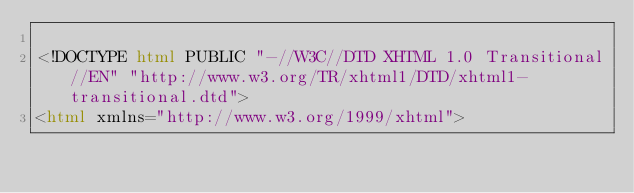Convert code to text. <code><loc_0><loc_0><loc_500><loc_500><_HTML_>
<!DOCTYPE html PUBLIC "-//W3C//DTD XHTML 1.0 Transitional//EN" "http://www.w3.org/TR/xhtml1/DTD/xhtml1-transitional.dtd">
<html xmlns="http://www.w3.org/1999/xhtml"></code> 